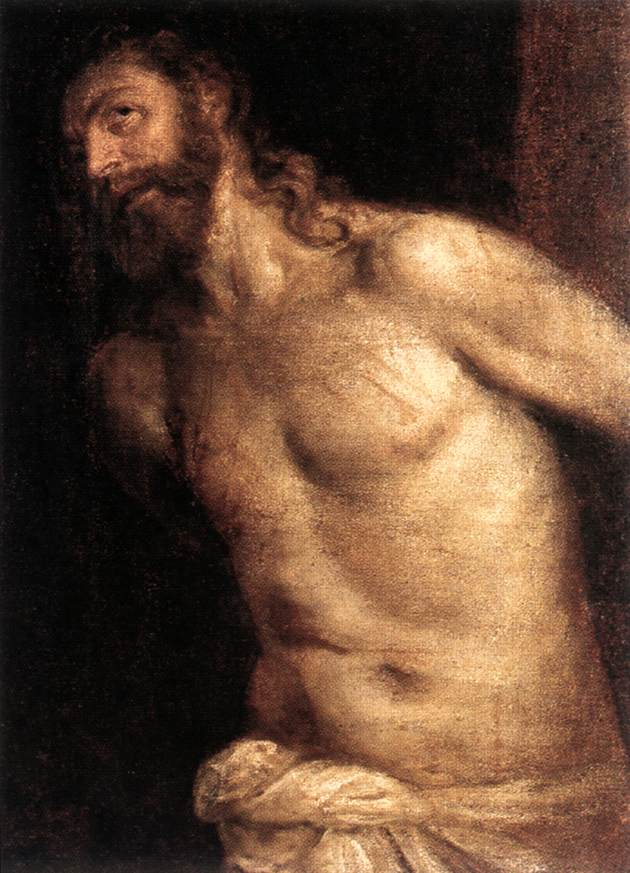What might the expression and eyes of the figure tell us about his emotional state or the story being portrayed? The figure’s eyes, looking away and slightly upward, combined with the soft illumination of his face, suggest a moment of deep introspection or prayer. This could indicate a narrative of martyrdom or prophecy, aligning with the common themes in biblical artwork. His expression carries a meditative quality, almost serene yet tinged with sadness, which might reflect his acceptance of fate or a moment of spiritual revelation. 